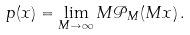Convert formula to latex. <formula><loc_0><loc_0><loc_500><loc_500>p ( x ) = \lim _ { M \to \infty } M \mathcal { P } _ { M } ( M x ) \, .</formula> 